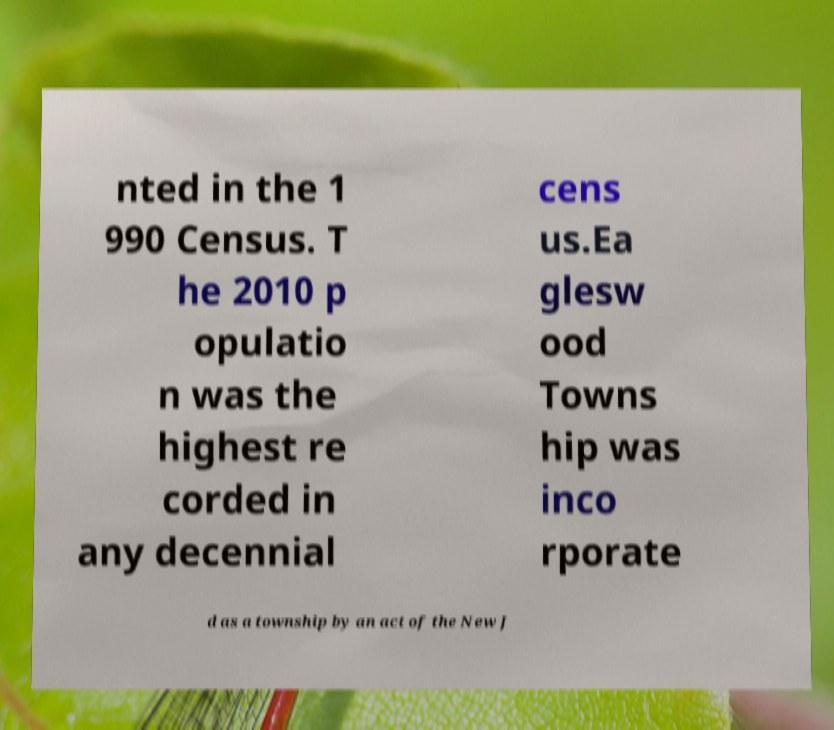Could you extract and type out the text from this image? nted in the 1 990 Census. T he 2010 p opulatio n was the highest re corded in any decennial cens us.Ea glesw ood Towns hip was inco rporate d as a township by an act of the New J 